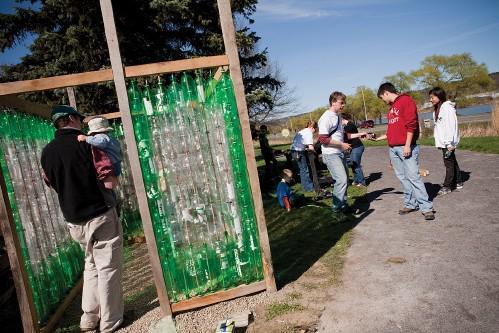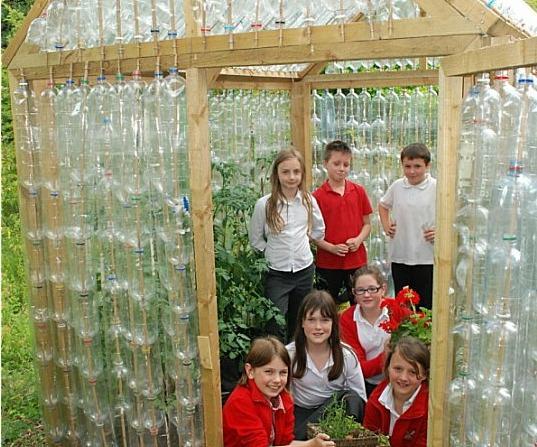The first image is the image on the left, the second image is the image on the right. Examine the images to the left and right. Is the description "Both images contain walls made of bottles." accurate? Answer yes or no. Yes. 